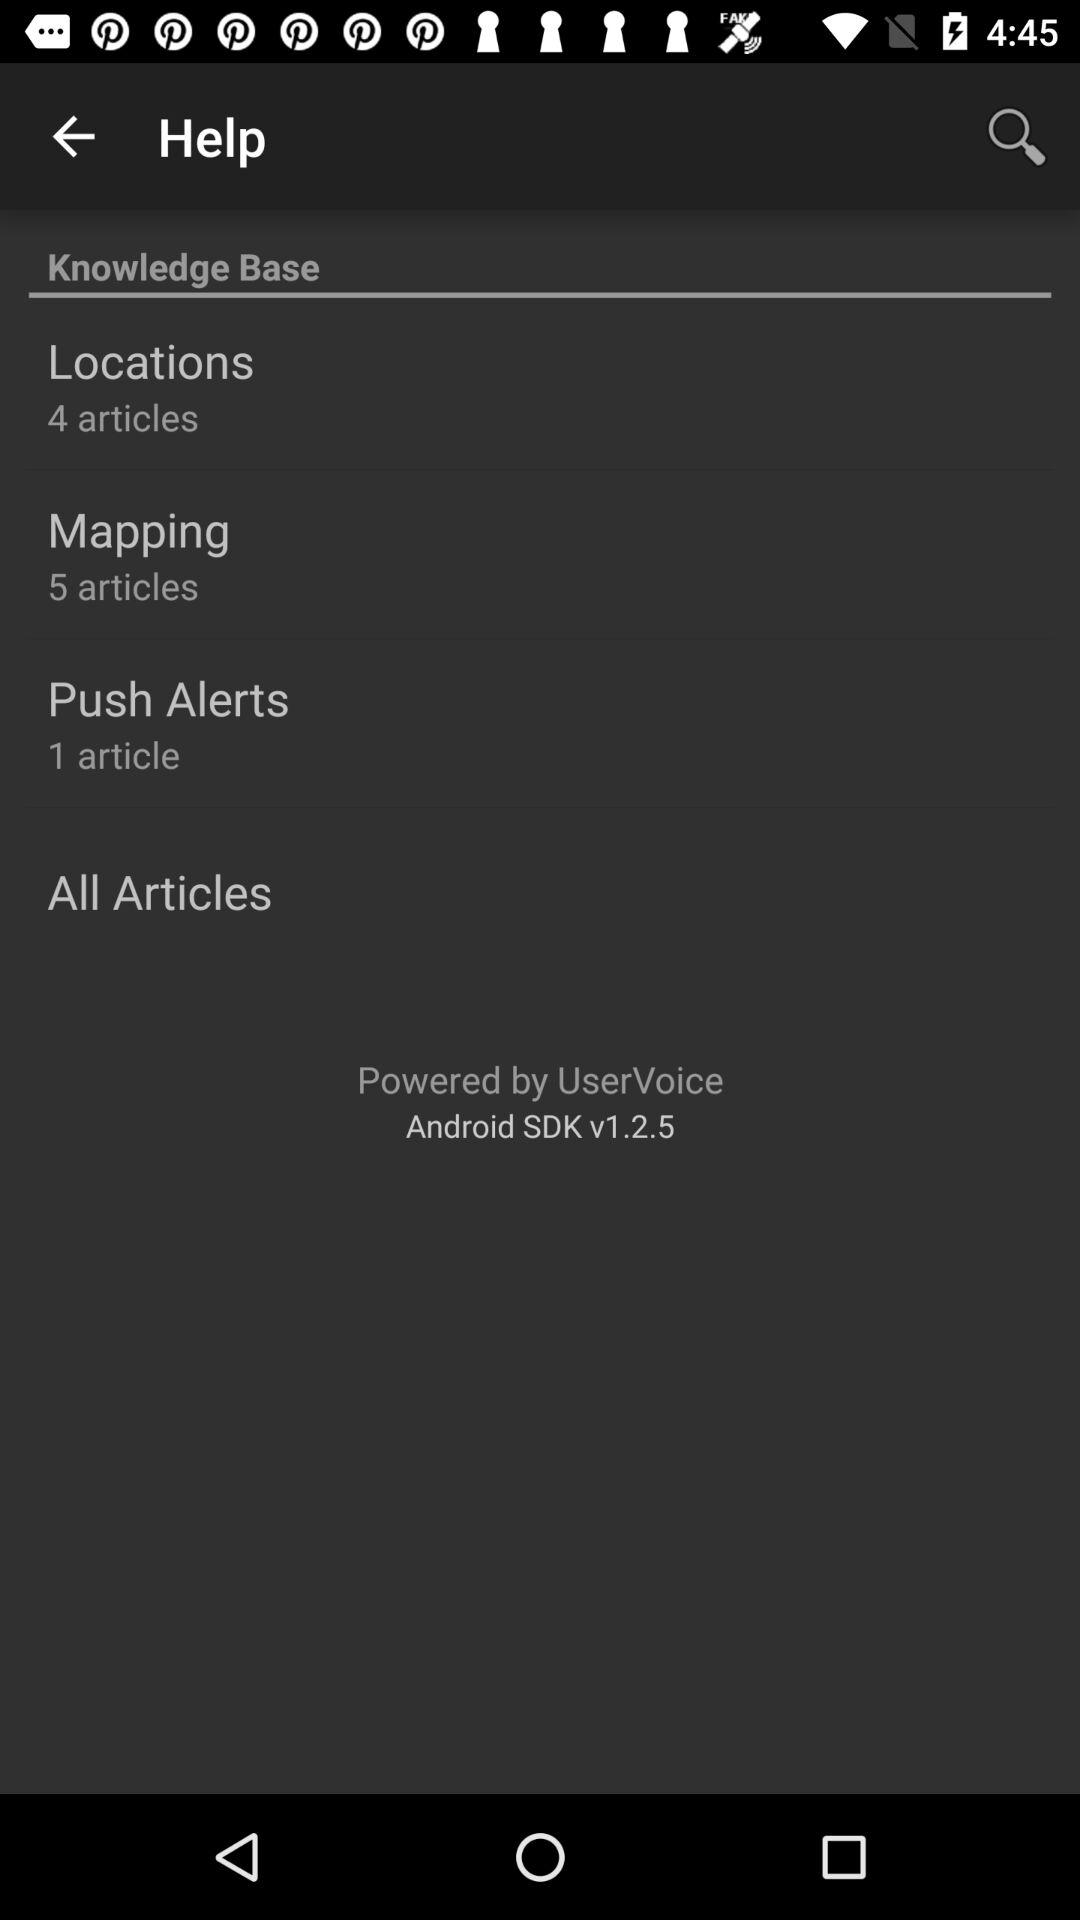How many articles belong to the push alerts? The number of articles is 1. 